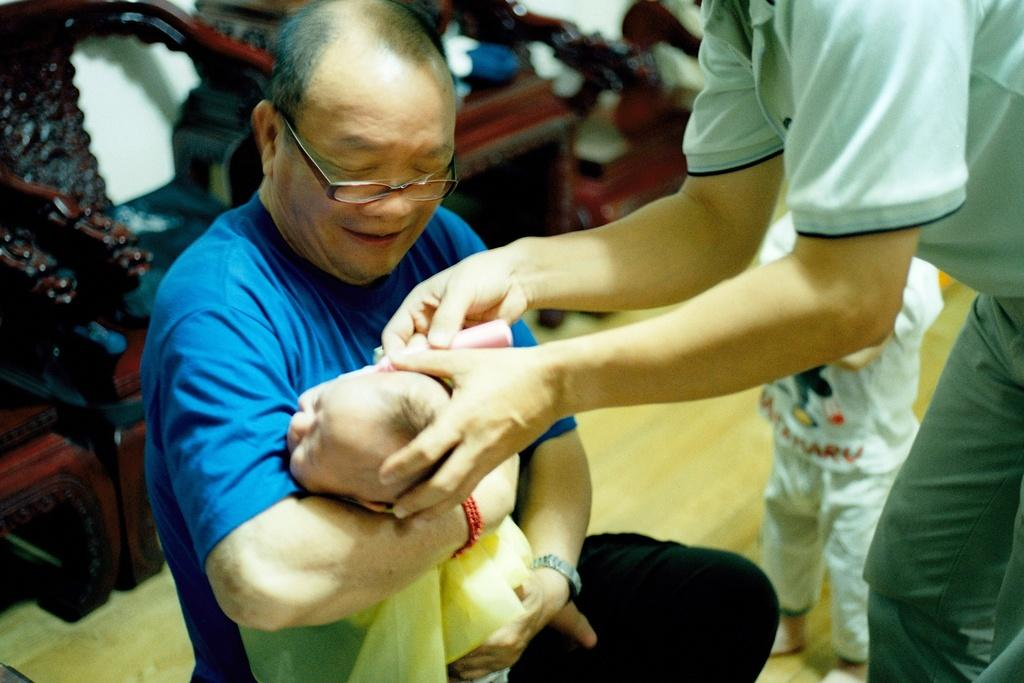How many people are in the image? There are people in the image, but the exact number is not specified. What is one person doing in the image? One person is carrying a baby in the image. What is the other person holding in the image? Another person is holding an object in the image. What can be seen in the background of the image? There are objects visible in the background, and there is a wall in the background. What type of range is visible in the image? There is no range present in the image. How many trays are being used by the people in the image? The facts do not mention any trays being used by the people in the image. 